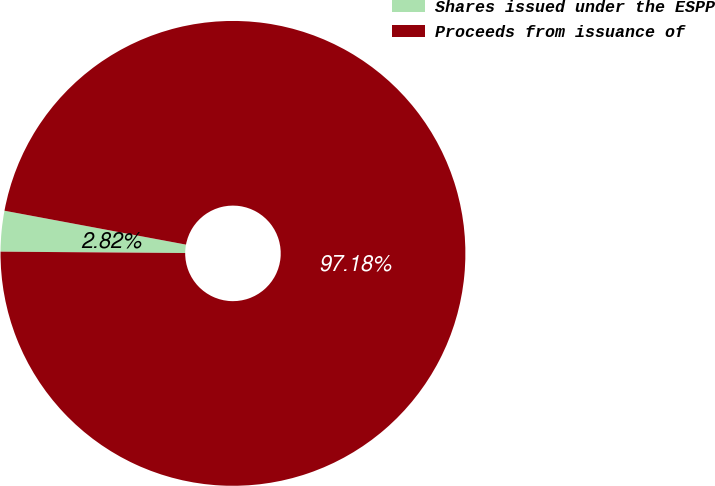Convert chart to OTSL. <chart><loc_0><loc_0><loc_500><loc_500><pie_chart><fcel>Shares issued under the ESPP<fcel>Proceeds from issuance of<nl><fcel>2.82%<fcel>97.18%<nl></chart> 